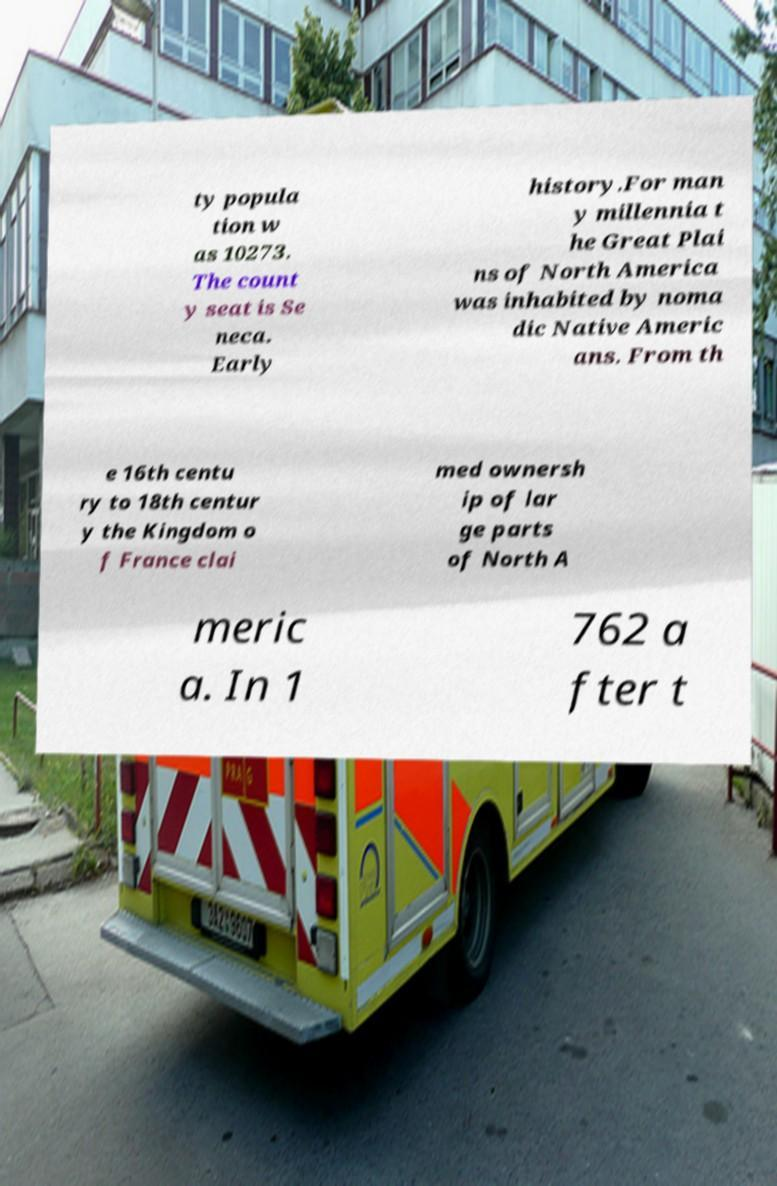Can you read and provide the text displayed in the image?This photo seems to have some interesting text. Can you extract and type it out for me? ty popula tion w as 10273. The count y seat is Se neca. Early history.For man y millennia t he Great Plai ns of North America was inhabited by noma dic Native Americ ans. From th e 16th centu ry to 18th centur y the Kingdom o f France clai med ownersh ip of lar ge parts of North A meric a. In 1 762 a fter t 